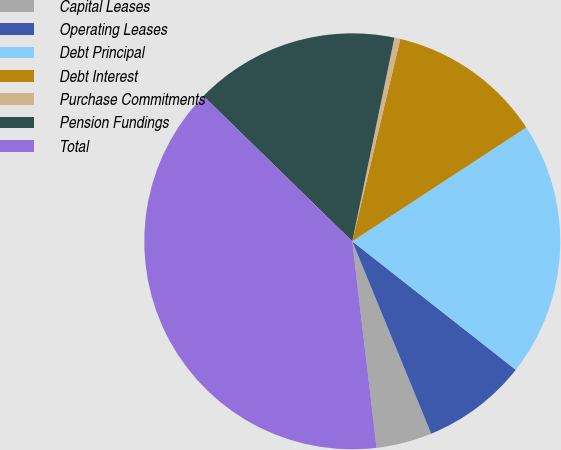Convert chart to OTSL. <chart><loc_0><loc_0><loc_500><loc_500><pie_chart><fcel>Capital Leases<fcel>Operating Leases<fcel>Debt Principal<fcel>Debt Interest<fcel>Purchase Commitments<fcel>Pension Fundings<fcel>Total<nl><fcel>4.33%<fcel>8.2%<fcel>19.82%<fcel>12.07%<fcel>0.46%<fcel>15.94%<fcel>39.17%<nl></chart> 